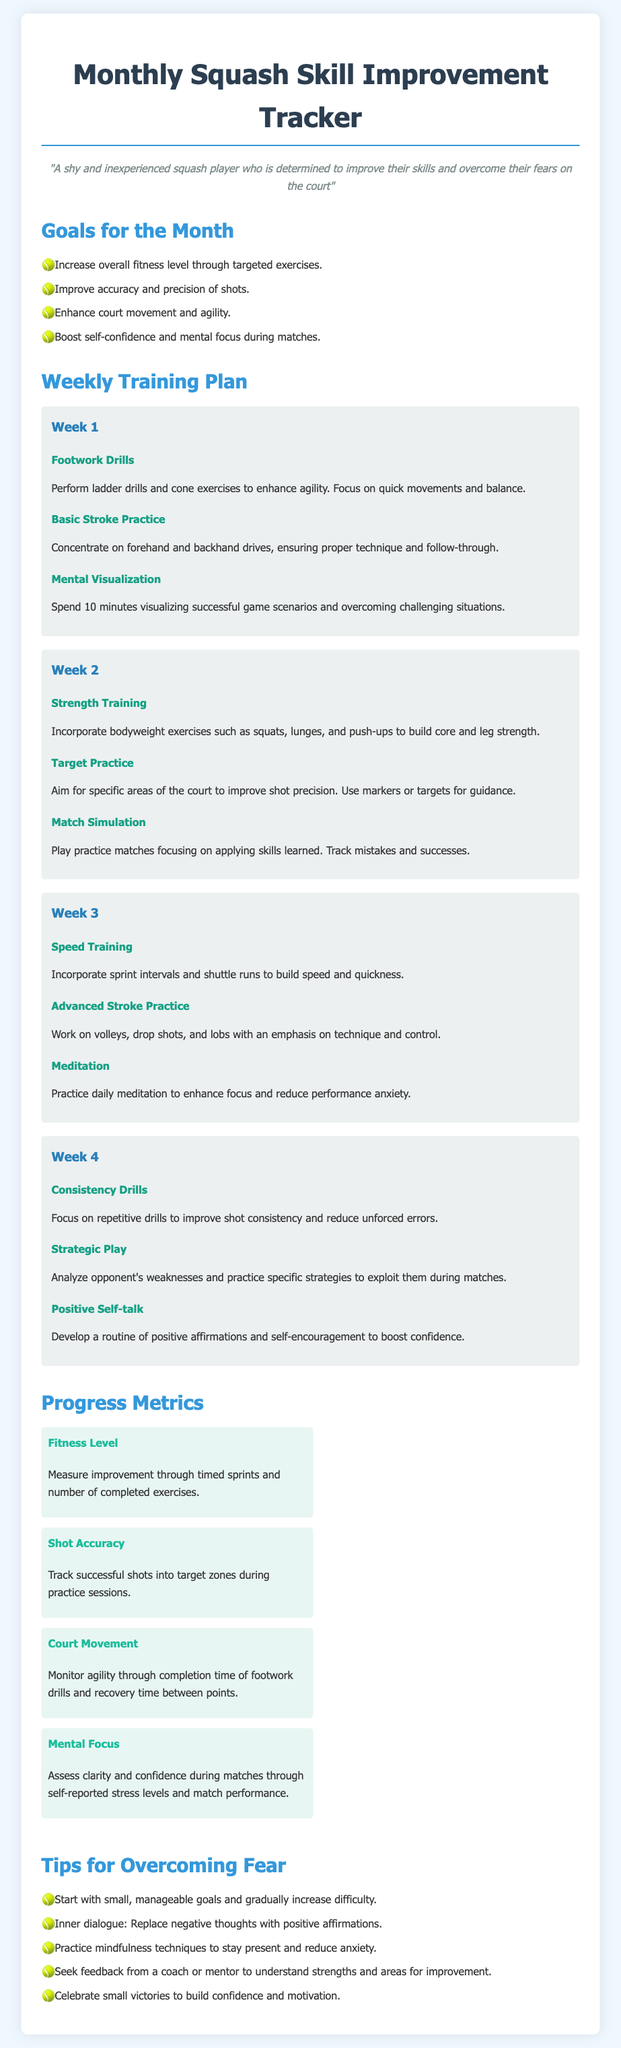What are the goals for the month? The goals for the month are listed in the document and include increasing overall fitness level, improving accuracy, enhancing court movement, and boosting self-confidence.
Answer: Increase overall fitness level, improve accuracy and precision of shots, enhance court movement and agility, boost self-confidence and mental focus during matches How many weeks are included in the training plan? The training plan outlines activities for four weeks, detailing specific exercises for each week.
Answer: 4 What type of drills are suggested for Week 1? Week 1 includes exercises focused on footwork drills, basic stroke practice, and mental visualization.
Answer: Footwork Drills, Basic Stroke Practice, Mental Visualization Which exercise focuses on shot precision in Week 2? The exercise in Week 2 aimed at improving shot precision is specifically mentioned as Target Practice.
Answer: Target Practice What is the focus of exercise in Week 3 related to mental preparation? The exercise in Week 3 aimed at mental preparation is meditation, designed to enhance focus and reduce performance anxiety.
Answer: Meditation What metric is used to measure fitness level? Fitness level is measured through timed sprints and the number of completed exercises, according to the progress metrics section.
Answer: Timed sprints and number of completed exercises What is one tip for overcoming fear mentioned in the document? The document provides multiple tips, one of which includes starting with small, manageable goals.
Answer: Start with small, manageable goals Which week involves strategic play as an exercise? Strategic play is noted as an exercise in Week 4, where the player analyzes opponents’ weaknesses.
Answer: Week 4 